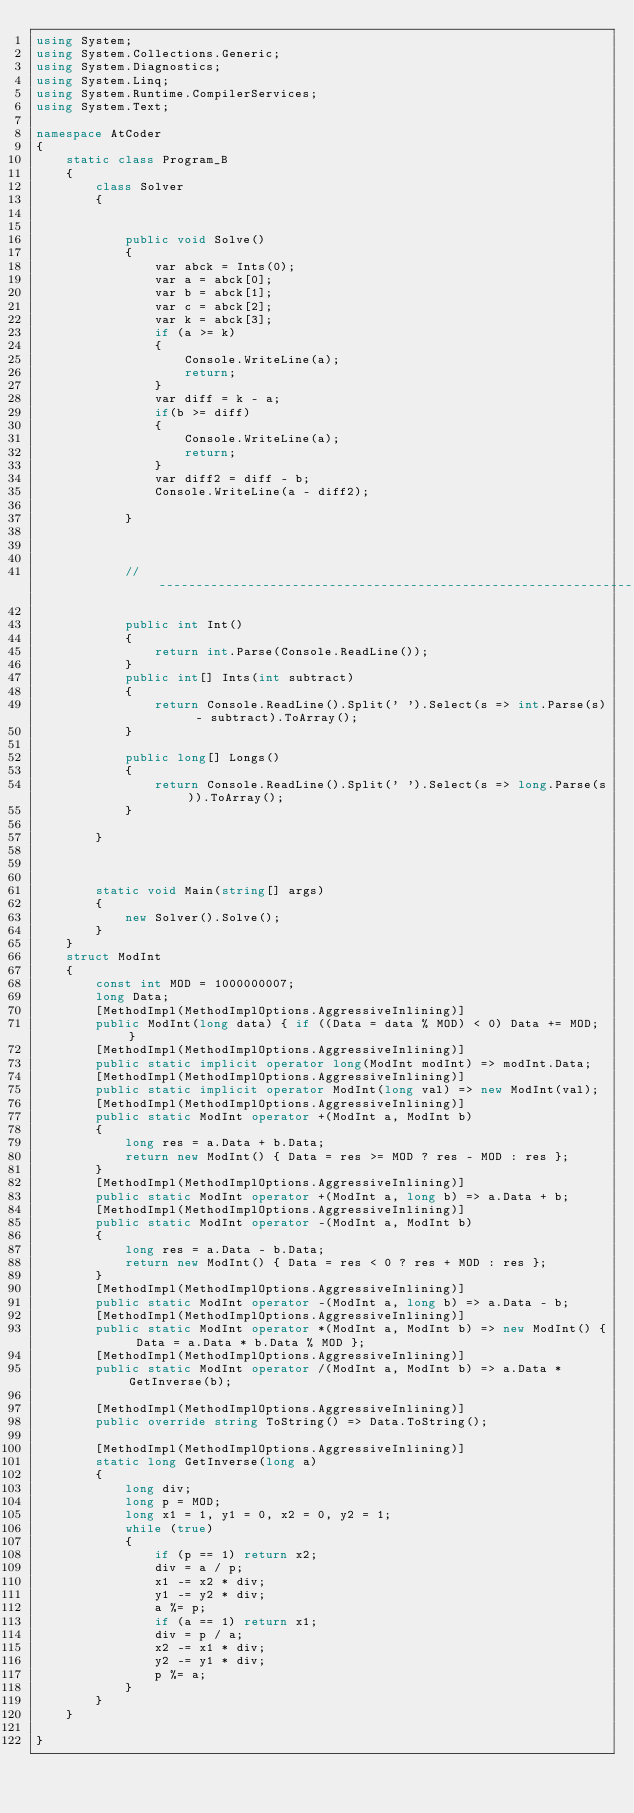Convert code to text. <code><loc_0><loc_0><loc_500><loc_500><_C#_>using System;
using System.Collections.Generic;
using System.Diagnostics;
using System.Linq;
using System.Runtime.CompilerServices;
using System.Text;

namespace AtCoder
{
    static class Program_B
    {
        class Solver
        {


            public void Solve()
            {
                var abck = Ints(0);
                var a = abck[0];
                var b = abck[1];
                var c = abck[2];
                var k = abck[3];
                if (a >= k)
                {
                    Console.WriteLine(a);
                    return;
                }
                var diff = k - a;
                if(b >= diff)
                {
                    Console.WriteLine(a);
                    return;
                }
                var diff2 = diff - b;
                Console.WriteLine(a - diff2);

            }



            // ----------------------------------------------------------------------------

            public int Int()
            {
                return int.Parse(Console.ReadLine());
            }
            public int[] Ints(int subtract)
            {
                return Console.ReadLine().Split(' ').Select(s => int.Parse(s) - subtract).ToArray();
            }

            public long[] Longs()
            {
                return Console.ReadLine().Split(' ').Select(s => long.Parse(s)).ToArray();
            }

        }



        static void Main(string[] args)
        {
            new Solver().Solve();
        }
    }
    struct ModInt
    {
        const int MOD = 1000000007;
        long Data;
        [MethodImpl(MethodImplOptions.AggressiveInlining)]
        public ModInt(long data) { if ((Data = data % MOD) < 0) Data += MOD; }
        [MethodImpl(MethodImplOptions.AggressiveInlining)]
        public static implicit operator long(ModInt modInt) => modInt.Data;
        [MethodImpl(MethodImplOptions.AggressiveInlining)]
        public static implicit operator ModInt(long val) => new ModInt(val);
        [MethodImpl(MethodImplOptions.AggressiveInlining)]
        public static ModInt operator +(ModInt a, ModInt b)
        {
            long res = a.Data + b.Data;
            return new ModInt() { Data = res >= MOD ? res - MOD : res };
        }
        [MethodImpl(MethodImplOptions.AggressiveInlining)]
        public static ModInt operator +(ModInt a, long b) => a.Data + b;
        [MethodImpl(MethodImplOptions.AggressiveInlining)]
        public static ModInt operator -(ModInt a, ModInt b)
        {
            long res = a.Data - b.Data;
            return new ModInt() { Data = res < 0 ? res + MOD : res };
        }
        [MethodImpl(MethodImplOptions.AggressiveInlining)]
        public static ModInt operator -(ModInt a, long b) => a.Data - b;
        [MethodImpl(MethodImplOptions.AggressiveInlining)]
        public static ModInt operator *(ModInt a, ModInt b) => new ModInt() { Data = a.Data * b.Data % MOD };
        [MethodImpl(MethodImplOptions.AggressiveInlining)]
        public static ModInt operator /(ModInt a, ModInt b) => a.Data * GetInverse(b);

        [MethodImpl(MethodImplOptions.AggressiveInlining)]
        public override string ToString() => Data.ToString();

        [MethodImpl(MethodImplOptions.AggressiveInlining)]
        static long GetInverse(long a)
        {
            long div;
            long p = MOD;
            long x1 = 1, y1 = 0, x2 = 0, y2 = 1;
            while (true)
            {
                if (p == 1) return x2;
                div = a / p;
                x1 -= x2 * div;
                y1 -= y2 * div;
                a %= p;
                if (a == 1) return x1;
                div = p / a;
                x2 -= x1 * div;
                y2 -= y1 * div;
                p %= a;
            }
        }
    }

}
</code> 